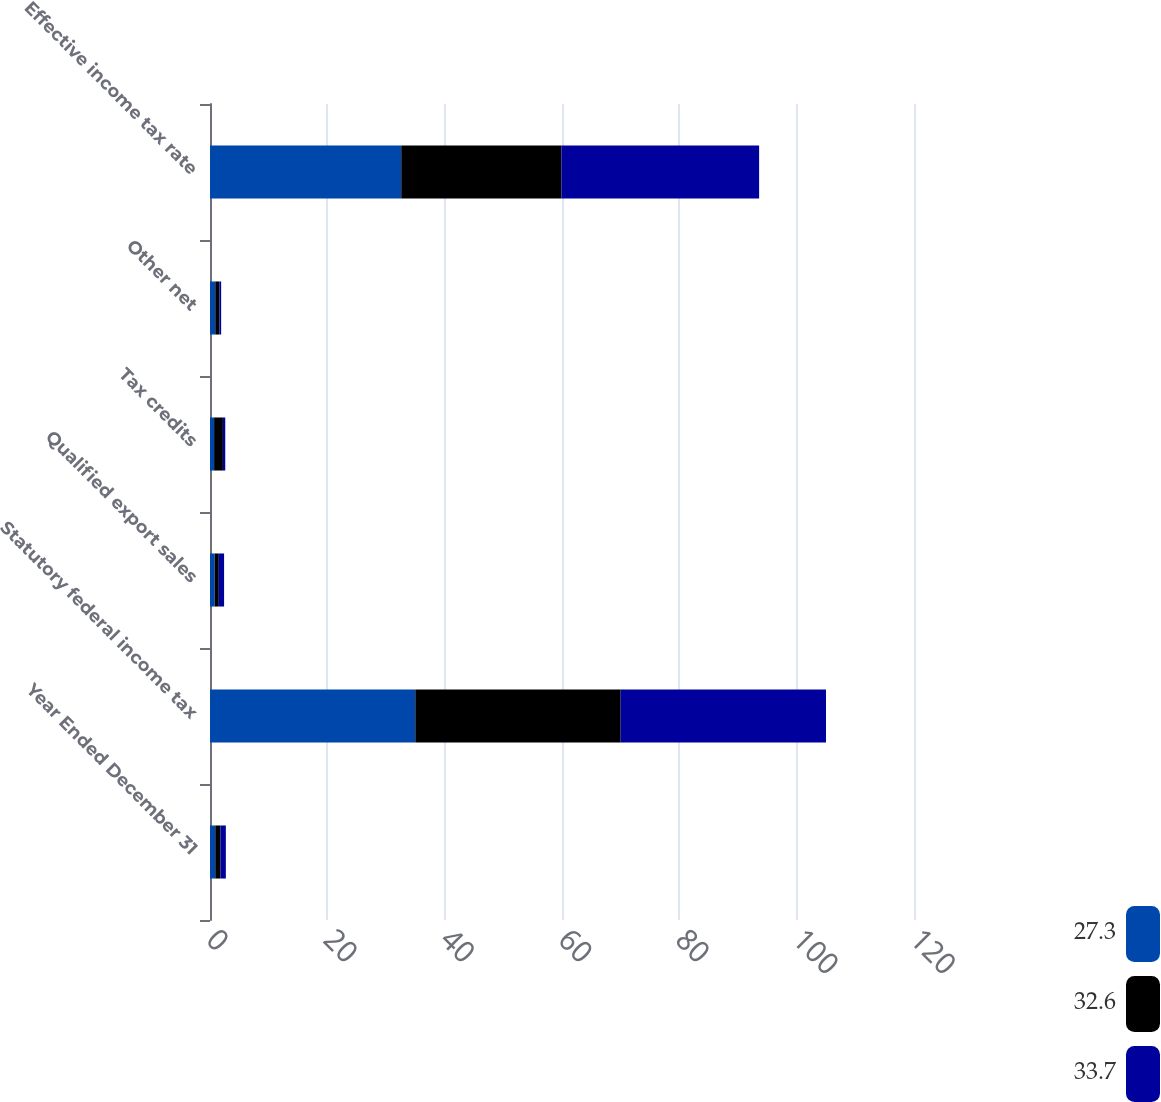Convert chart to OTSL. <chart><loc_0><loc_0><loc_500><loc_500><stacked_bar_chart><ecel><fcel>Year Ended December 31<fcel>Statutory federal income tax<fcel>Qualified export sales<fcel>Tax credits<fcel>Other net<fcel>Effective income tax rate<nl><fcel>27.3<fcel>0.9<fcel>35<fcel>0.8<fcel>0.7<fcel>0.9<fcel>32.6<nl><fcel>32.6<fcel>0.9<fcel>35<fcel>0.7<fcel>1.5<fcel>0.7<fcel>27.3<nl><fcel>33.7<fcel>0.9<fcel>35<fcel>0.9<fcel>0.4<fcel>0.3<fcel>33.7<nl></chart> 